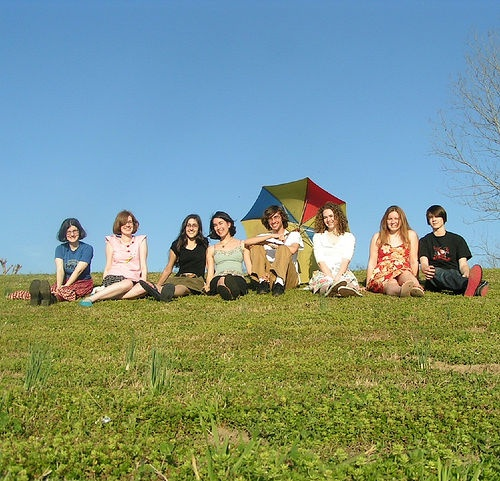Describe the objects in this image and their specific colors. I can see people in gray, black, salmon, and brown tones, people in gray and tan tones, people in gray, tan, black, and ivory tones, umbrella in gray, olive, tan, and blue tones, and people in gray, ivory, olive, tan, and maroon tones in this image. 